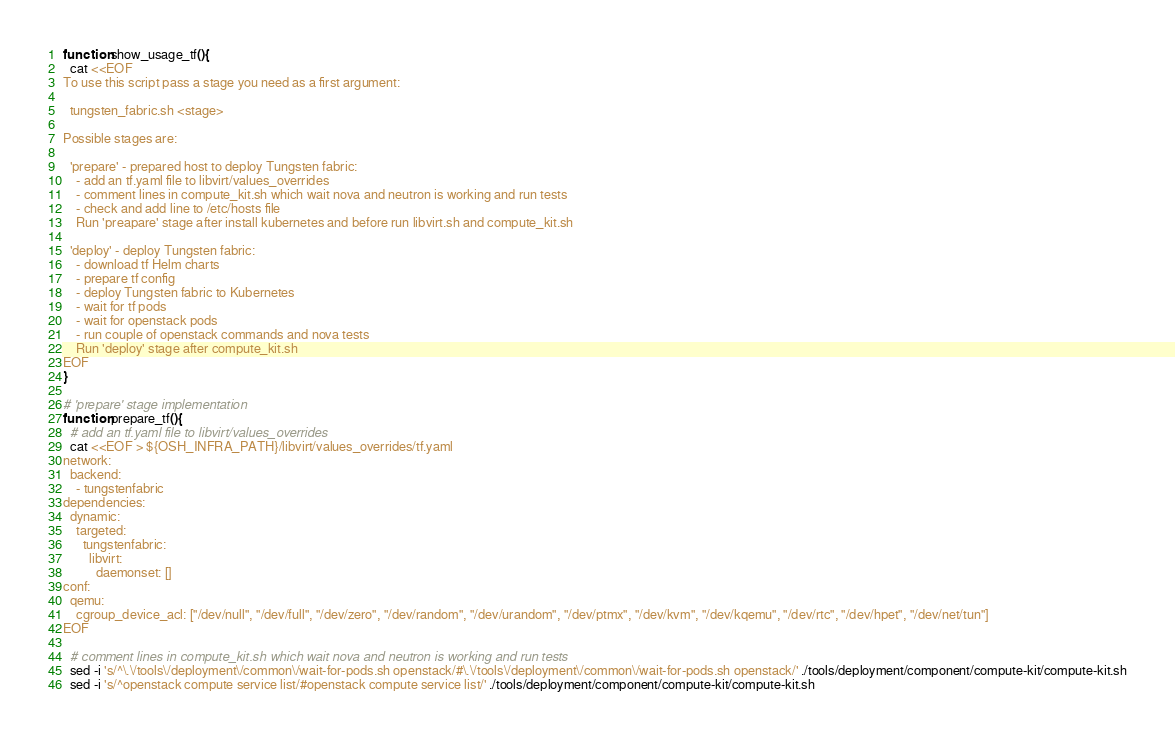Convert code to text. <code><loc_0><loc_0><loc_500><loc_500><_Bash_>
function show_usage_tf(){
  cat <<EOF
To use this script pass a stage you need as a first argument:

  tungsten_fabric.sh <stage>

Possible stages are:

  'prepare' - prepared host to deploy Tungsten fabric:
    - add an tf.yaml file to libvirt/values_overrides
    - comment lines in compute_kit.sh which wait nova and neutron is working and run tests
    - check and add line to /etc/hosts file
    Run 'preapare' stage after install kubernetes and before run libvirt.sh and compute_kit.sh

  'deploy' - deploy Tungsten fabric:
    - download tf Helm charts
    - prepare tf config
    - deploy Tungsten fabric to Kubernetes
    - wait for tf pods
    - wait for openstack pods
    - run couple of openstack commands and nova tests
    Run 'deploy' stage after compute_kit.sh
EOF
}

# 'prepare' stage implementation
function prepare_tf(){
  # add an tf.yaml file to libvirt/values_overrides
  cat <<EOF > ${OSH_INFRA_PATH}/libvirt/values_overrides/tf.yaml
network:
  backend:
    - tungstenfabric
dependencies:
  dynamic:
    targeted:
      tungstenfabric:
        libvirt:
          daemonset: []
conf:
  qemu:
    cgroup_device_acl: ["/dev/null", "/dev/full", "/dev/zero", "/dev/random", "/dev/urandom", "/dev/ptmx", "/dev/kvm", "/dev/kqemu", "/dev/rtc", "/dev/hpet", "/dev/net/tun"]
EOF

  # comment lines in compute_kit.sh which wait nova and neutron is working and run tests
  sed -i 's/^\.\/tools\/deployment\/common\/wait-for-pods.sh openstack/#\.\/tools\/deployment\/common\/wait-for-pods.sh openstack/' ./tools/deployment/component/compute-kit/compute-kit.sh
  sed -i 's/^openstack compute service list/#openstack compute service list/' ./tools/deployment/component/compute-kit/compute-kit.sh</code> 